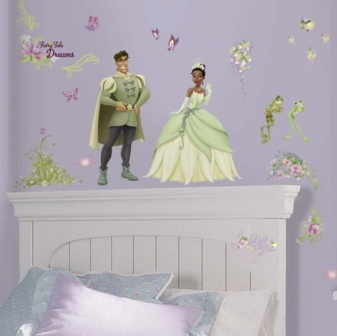Imagine the fairy-tale-like adventure the prince, princess, and frog are embarking on. In this fanciful adventure, the prince and princess, accompanied by their friend the frog, set off on a journey to a magical kingdom hidden deep in an enchanted forest. Along the way, they encounter talking animals, solve ancient puzzles, and brave mysterious landscapes, all in a quest to restore a long-lost artifact that promises to bring everlasting peace and prosperity to their realm. Their courage and friendship are tested, but in the end, they triumph over adversity, returning home as celebrated heroes. 